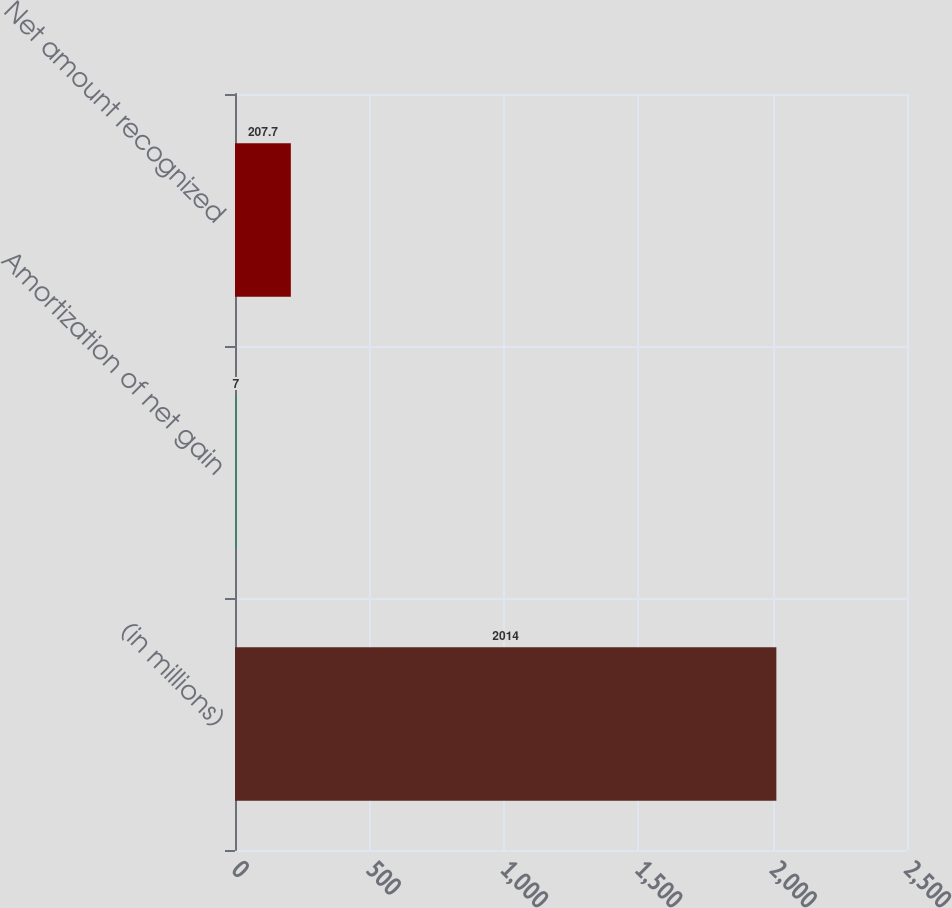<chart> <loc_0><loc_0><loc_500><loc_500><bar_chart><fcel>(in millions)<fcel>Amortization of net gain<fcel>Net amount recognized<nl><fcel>2014<fcel>7<fcel>207.7<nl></chart> 